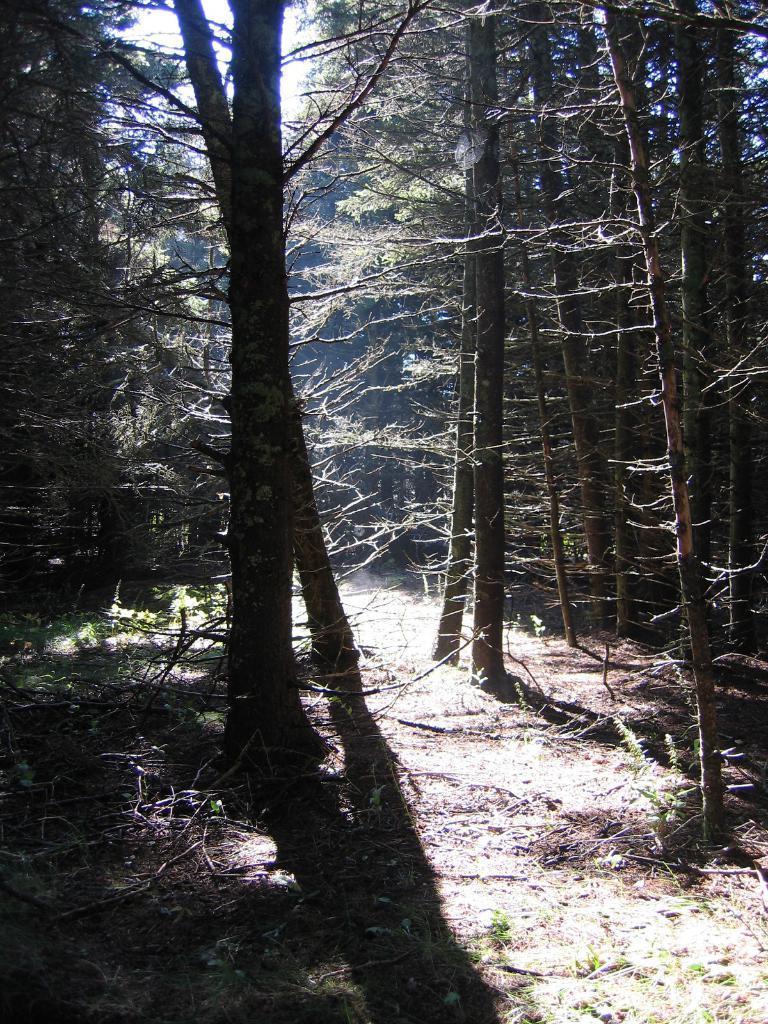How would you summarize this image in a sentence or two? In this picture we can see trees and on the path there are branches. Behind the trees there is the sky. 